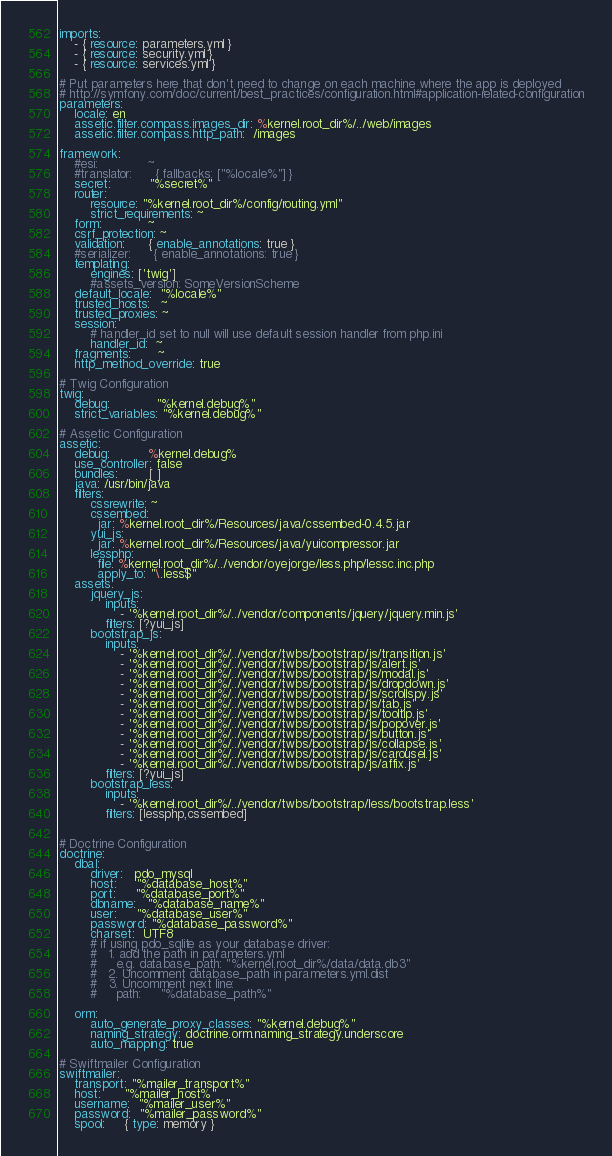Convert code to text. <code><loc_0><loc_0><loc_500><loc_500><_YAML_>imports:
    - { resource: parameters.yml }
    - { resource: security.yml }
    - { resource: services.yml }

# Put parameters here that don't need to change on each machine where the app is deployed
# http://symfony.com/doc/current/best_practices/configuration.html#application-related-configuration
parameters:
    locale: en
    assetic.filter.compass.images_dir: %kernel.root_dir%/../web/images
    assetic.filter.compass.http_path:  /images

framework:
    #esi:             ~
    #translator:      { fallbacks: ["%locale%"] }
    secret:          "%secret%"
    router:
        resource: "%kernel.root_dir%/config/routing.yml"
        strict_requirements: ~
    form:            ~
    csrf_protection: ~
    validation:      { enable_annotations: true }
    #serializer:      { enable_annotations: true }
    templating:
        engines: ['twig']
        #assets_version: SomeVersionScheme
    default_locale:  "%locale%"
    trusted_hosts:   ~
    trusted_proxies: ~
    session:
        # handler_id set to null will use default session handler from php.ini
        handler_id:  ~
    fragments:       ~
    http_method_override: true

# Twig Configuration
twig:
    debug:            "%kernel.debug%"
    strict_variables: "%kernel.debug%"

# Assetic Configuration
assetic:
    debug:          %kernel.debug%
    use_controller: false
    bundles:        [ ]
    java: /usr/bin/java
    filters:
        cssrewrite: ~
        cssembed:
          jar: %kernel.root_dir%/Resources/java/cssembed-0.4.5.jar
        yui_js:
          jar: %kernel.root_dir%/Resources/java/yuicompressor.jar
        lessphp:
          file: %kernel.root_dir%/../vendor/oyejorge/less.php/lessc.inc.php
          apply_to: "\.less$"
    assets:
        jquery_js:
            inputs:
                - '%kernel.root_dir%/../vendor/components/jquery/jquery.min.js'
            filters: [?yui_js]
        bootstrap_js:
            inputs:
                - '%kernel.root_dir%/../vendor/twbs/bootstrap/js/transition.js'
                - '%kernel.root_dir%/../vendor/twbs/bootstrap/js/alert.js'
                - '%kernel.root_dir%/../vendor/twbs/bootstrap/js/modal.js'
                - '%kernel.root_dir%/../vendor/twbs/bootstrap/js/dropdown.js'
                - '%kernel.root_dir%/../vendor/twbs/bootstrap/js/scrollspy.js'
                - '%kernel.root_dir%/../vendor/twbs/bootstrap/js/tab.js'
                - '%kernel.root_dir%/../vendor/twbs/bootstrap/js/tooltip.js'
                - '%kernel.root_dir%/../vendor/twbs/bootstrap/js/popover.js'
                - '%kernel.root_dir%/../vendor/twbs/bootstrap/js/button.js'
                - '%kernel.root_dir%/../vendor/twbs/bootstrap/js/collapse.js'
                - '%kernel.root_dir%/../vendor/twbs/bootstrap/js/carousel.js'
                - '%kernel.root_dir%/../vendor/twbs/bootstrap/js/affix.js'
            filters: [?yui_js]
        bootstrap_less:
            inputs:
                - '%kernel.root_dir%/../vendor/twbs/bootstrap/less/bootstrap.less'
            filters: [lessphp,cssembed]


# Doctrine Configuration
doctrine:
    dbal:
        driver:   pdo_mysql
        host:     "%database_host%"
        port:     "%database_port%"
        dbname:   "%database_name%"
        user:     "%database_user%"
        password: "%database_password%"
        charset:  UTF8
        # if using pdo_sqlite as your database driver:
        #   1. add the path in parameters.yml
        #     e.g. database_path: "%kernel.root_dir%/data/data.db3"
        #   2. Uncomment database_path in parameters.yml.dist
        #   3. Uncomment next line:
        #     path:     "%database_path%"

    orm:
        auto_generate_proxy_classes: "%kernel.debug%"
        naming_strategy: doctrine.orm.naming_strategy.underscore
        auto_mapping: true

# Swiftmailer Configuration
swiftmailer:
    transport: "%mailer_transport%"
    host:      "%mailer_host%"
    username:  "%mailer_user%"
    password:  "%mailer_password%"
    spool:     { type: memory }
</code> 